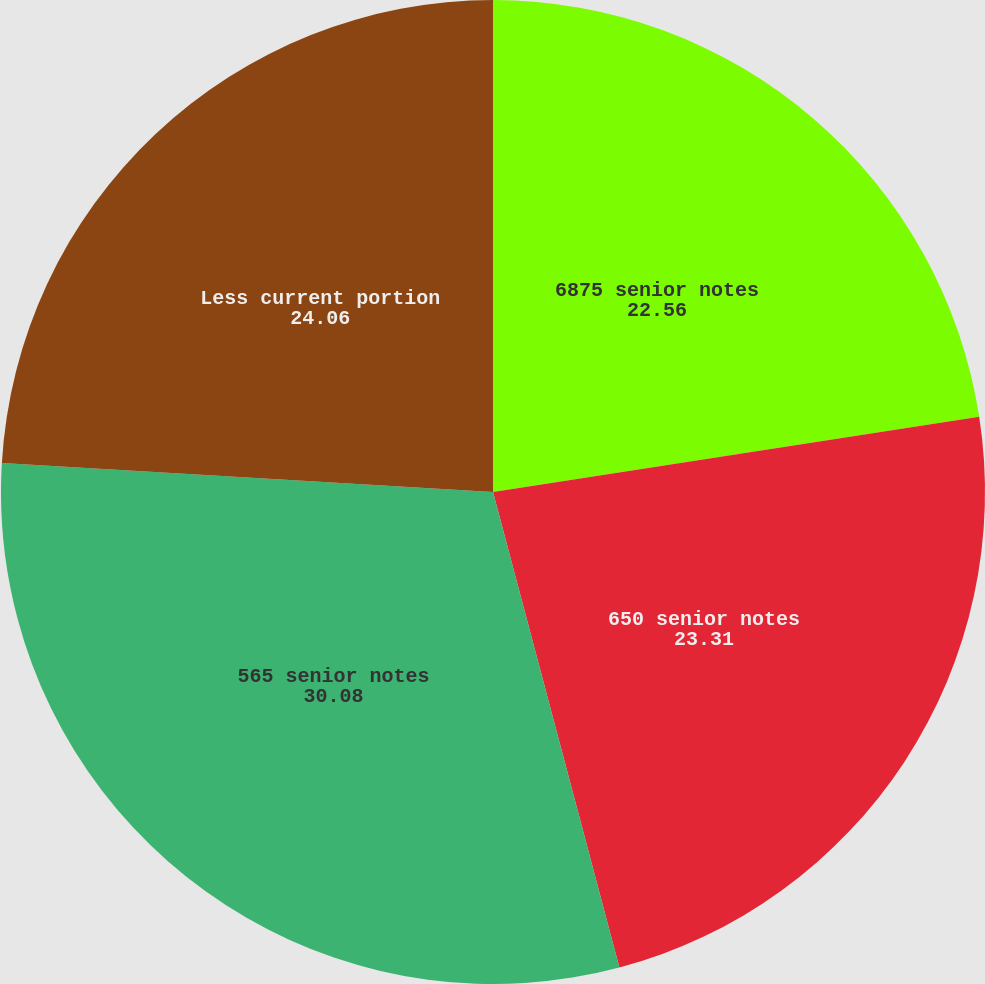<chart> <loc_0><loc_0><loc_500><loc_500><pie_chart><fcel>6875 senior notes<fcel>650 senior notes<fcel>565 senior notes<fcel>Less current portion<nl><fcel>22.56%<fcel>23.31%<fcel>30.08%<fcel>24.06%<nl></chart> 